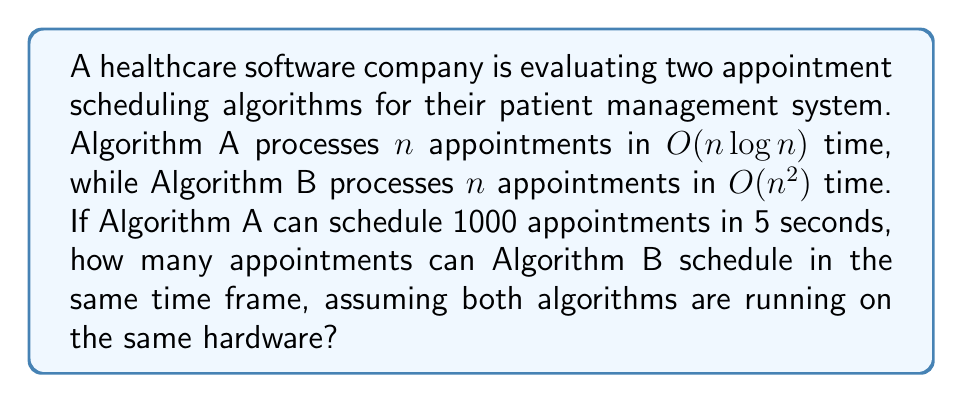Help me with this question. Let's approach this step-by-step:

1) First, we need to understand the time complexities:
   - Algorithm A: $O(n \log n)$
   - Algorithm B: $O(n^2)$

2) We know that Algorithm A can schedule 1000 appointments in 5 seconds. Let's call the number of appointments Algorithm B can schedule in 5 seconds $x$.

3) Since both algorithms are running on the same hardware for the same amount of time, we can set up an equation:

   $$(1000 \log 1000) \cdot k = x^2 \cdot k$$

   Where $k$ is a constant factor depending on the hardware.

4) The $k$ cancels out on both sides:

   $$1000 \log 1000 = x^2$$

5) Now, let's solve for $x$:

   $$x^2 = 1000 \log 1000$$
   $$x^2 = 1000 \cdot 3 = 3000$$
   $$x = \sqrt{3000} \approx 54.77$$

6) Since we can't schedule a fractional number of appointments, we round down to the nearest whole number.
Answer: Algorithm B can schedule 54 appointments in 5 seconds. 